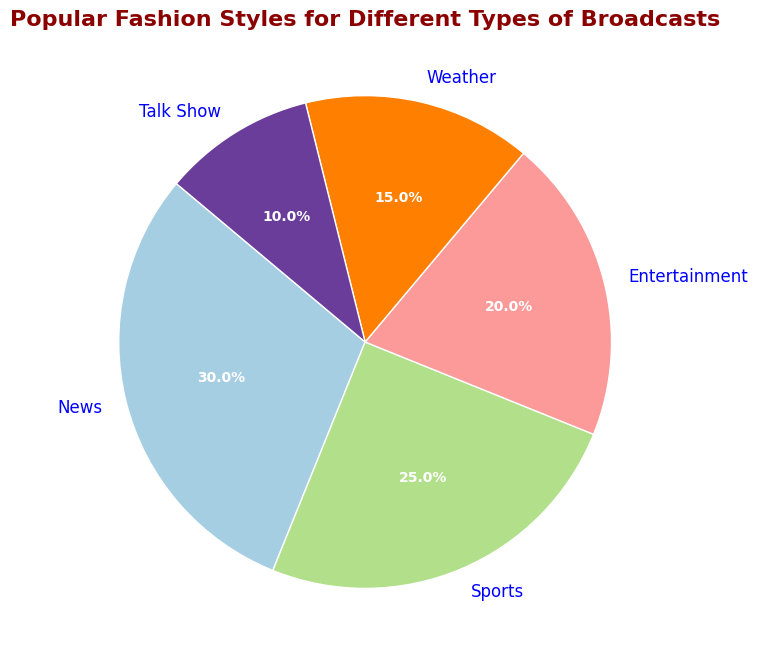What's the most popular fashion style for live broadcasts? The segment occupying the largest portion of the pie chart is the one representing news, which shows a percentage of 30%.
Answer: News What percentage of broadcasts are dedicated to sports and entertainment combined? To find the combined percentage, add the percentages for sports (25%) and entertainment (20%). So, 25% + 20% = 45%.
Answer: 45% Which fashion style is less popular: weather or talk shows? Compare the percentages for weather (15%) and talk shows (10%). Since 10% is less than 15%, talk shows are less popular.
Answer: Talk shows How much more popular is the news style compared to the talk show style? Subtract the percentage for talk shows (10%) from the percentage for news (30%). So, 30% - 10% = 20%.
Answer: 20% Rank the fashion styles from most popular to least popular. The percentages are News (30%), Sports (25%), Entertainment (20%), Weather (15%), Talk Show (10%). Rank them accordingly: News > Sports > Entertainment > Weather > Talk Show.
Answer: News > Sports > Entertainment > Weather > Talk Show Are sports broadcasts more or less popular than weather broadcasts? Compare the percentages for sports (25%) and weather (15%). Since 25% is more than 15%, sports broadcasts are more popular.
Answer: More popular If the pie chart were to be recreated with equally sized segments, what would be the percentage for each type? Since there are 5 types, divide 100% by 5. So, 100% / 5 = 20%.
Answer: 20% What is the total percentage of broadcasts that are neither sports nor weather? Add the percentages for news (30%), entertainment (20%), and talk show (10%). So, 30% + 20% + 10% = 60%.
Answer: 60% How does the proportion of entertainment broadcasts compare to the sum of weather and talk show broadcasts? Add the percentages for weather (15%) and talk show (10%), then compare to entertainment (20%). The sum is 15% + 10% = 25%, which is more than 20%.
Answer: Less 